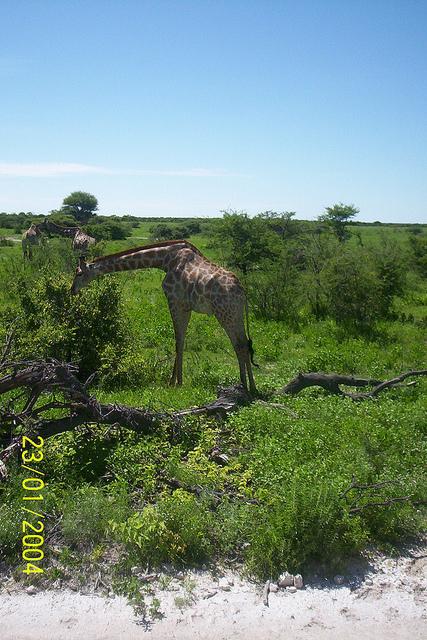Is this picture taken in Japan?
Give a very brief answer. No. How tall would you estimate the giraffe may be?
Write a very short answer. 20 feet. When was this picture taken?
Short answer required. 23/01/2004. 